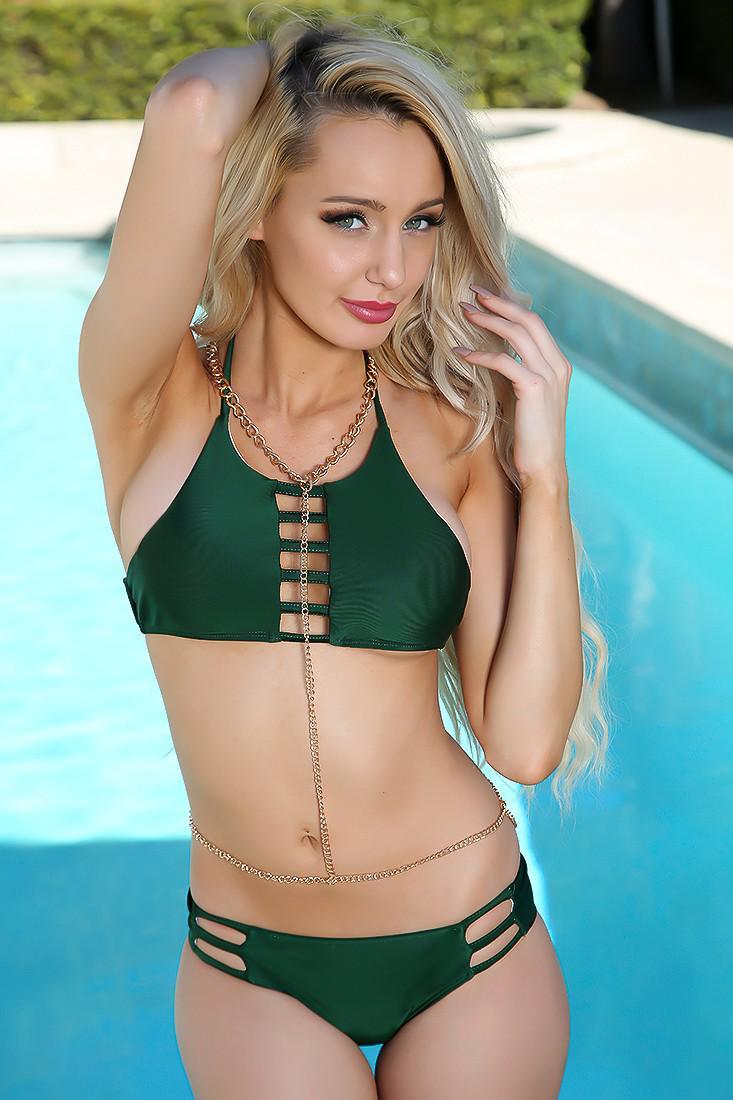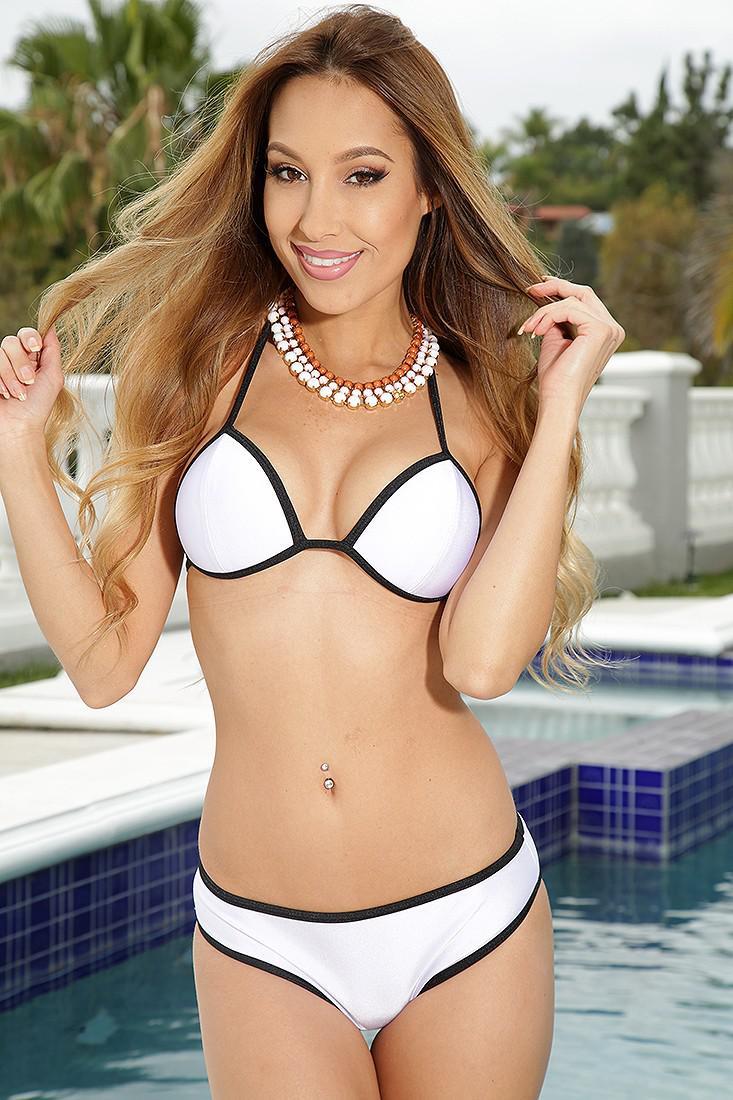The first image is the image on the left, the second image is the image on the right. Analyze the images presented: Is the assertion "There is one red bikini" valid? Answer yes or no. No. The first image is the image on the left, the second image is the image on the right. Considering the images on both sides, is "At least one image shows a model wearing a high-waisted bikini bottom that just reaches the navel." valid? Answer yes or no. No. 